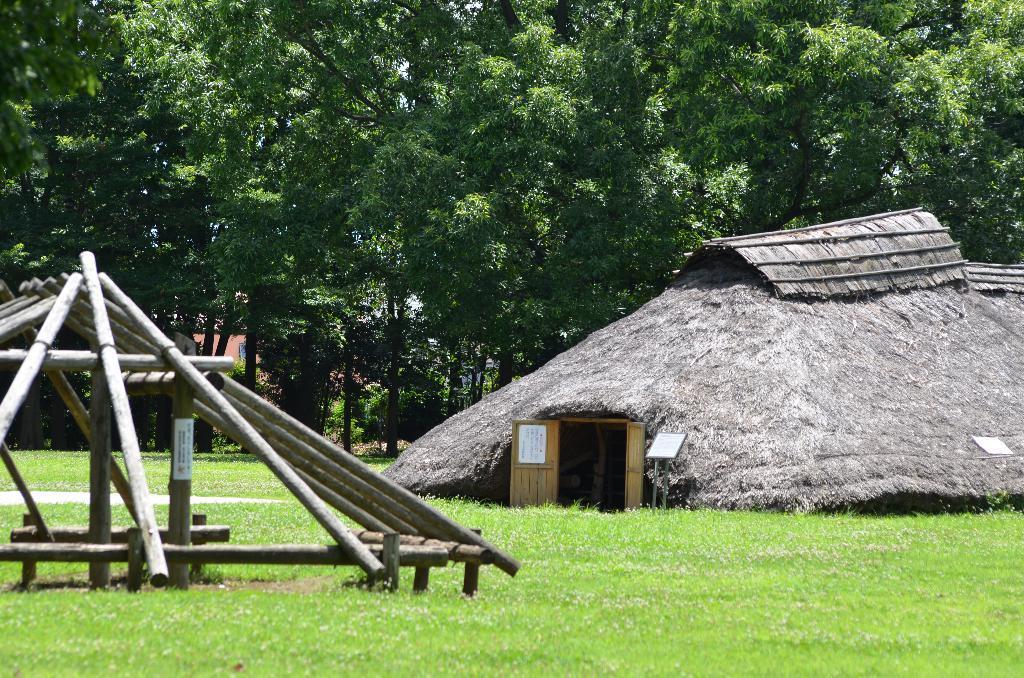In one or two sentences, can you explain what this image depicts? In this image, we can see green color grass on the ground, at the right side we can see a house and a door, there are some green color trees. 